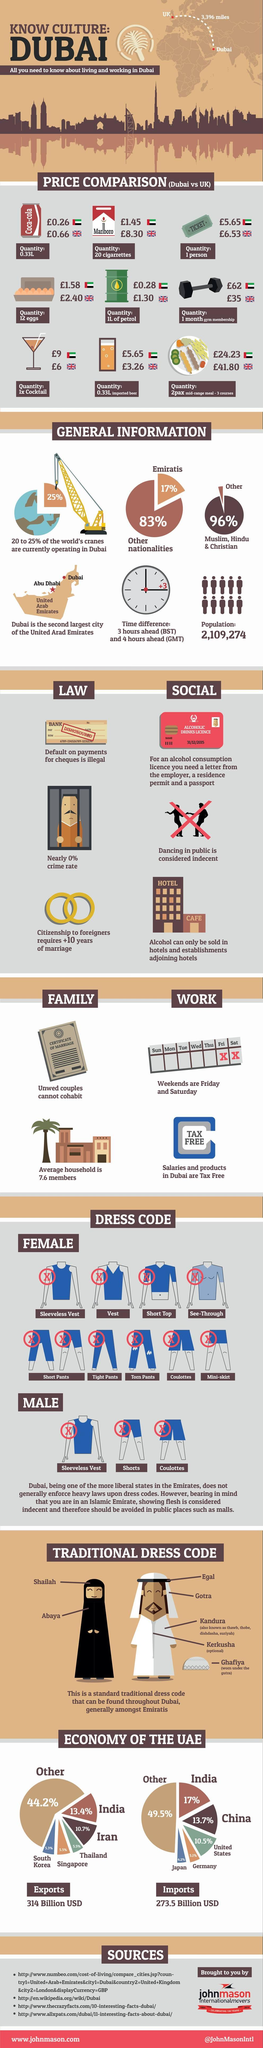Indicate a few pertinent items in this graphic. The price of 1 liter of petrol in Dubai is 1.02 pounds more than the price of 1 liter of petrol in the UK. Six out of the given products are more expensive in the UK than in Dubai. Out of the given products, three of them are cheaper in the United Kingdom than in Dubai. India and China combined account for approximately 30.7% of global imports. In the United Kingdom, beer is generally more expensive than in Dubai. However, in Dubai, beer is significantly more expensive than in the UK. 